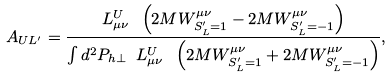Convert formula to latex. <formula><loc_0><loc_0><loc_500><loc_500>A _ { U L ^ { \prime } } = \frac { L _ { \mu \nu } ^ { U } \ \left ( 2 M W ^ { \mu \nu } _ { S _ { L } ^ { \prime } = 1 } - 2 M W ^ { \mu \nu } _ { S _ { L } ^ { \prime } = - 1 } \right ) } { \int d ^ { 2 } P _ { h \perp } \ L _ { \mu \nu } ^ { U } \ \left ( 2 M W ^ { \mu \nu } _ { S _ { L } ^ { \prime } = 1 } + 2 M W ^ { \mu \nu } _ { S _ { L } ^ { \prime } = - 1 } \right ) } ,</formula> 